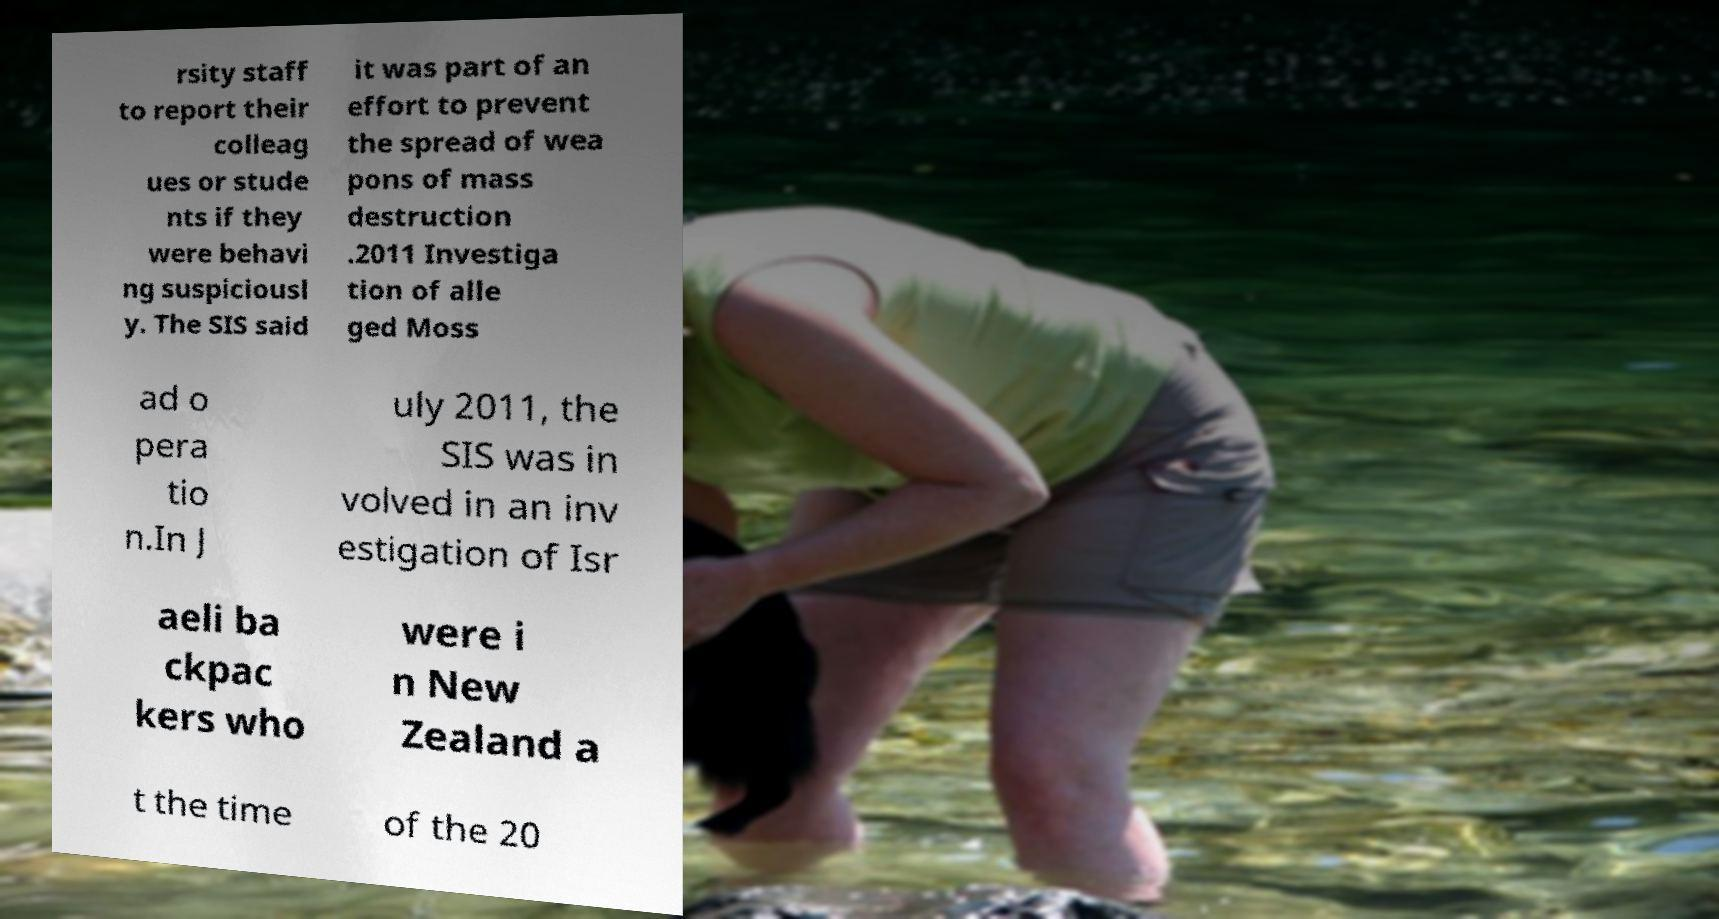I need the written content from this picture converted into text. Can you do that? rsity staff to report their colleag ues or stude nts if they were behavi ng suspiciousl y. The SIS said it was part of an effort to prevent the spread of wea pons of mass destruction .2011 Investiga tion of alle ged Moss ad o pera tio n.In J uly 2011, the SIS was in volved in an inv estigation of Isr aeli ba ckpac kers who were i n New Zealand a t the time of the 20 